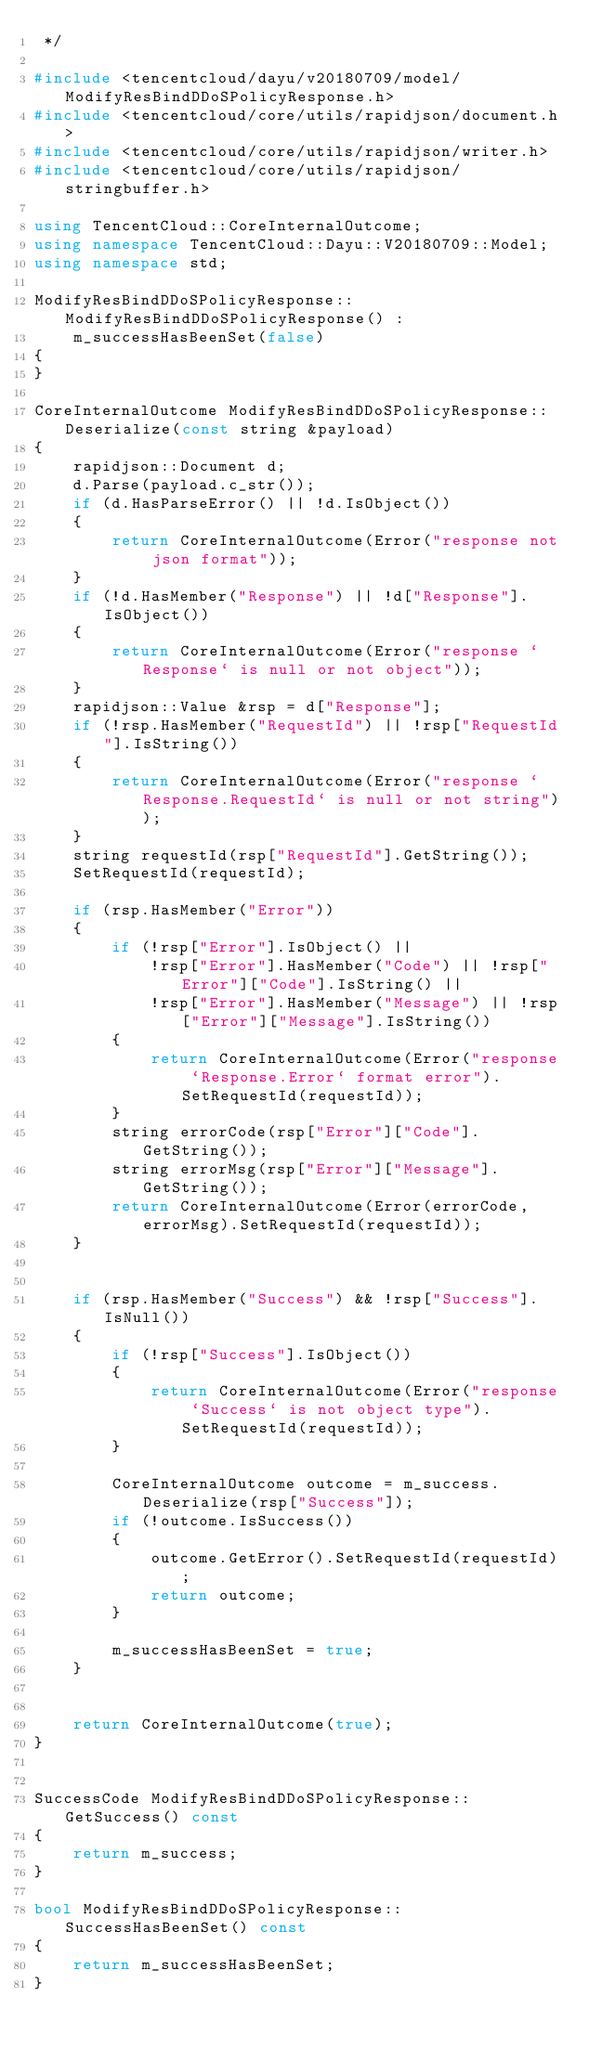Convert code to text. <code><loc_0><loc_0><loc_500><loc_500><_C++_> */

#include <tencentcloud/dayu/v20180709/model/ModifyResBindDDoSPolicyResponse.h>
#include <tencentcloud/core/utils/rapidjson/document.h>
#include <tencentcloud/core/utils/rapidjson/writer.h>
#include <tencentcloud/core/utils/rapidjson/stringbuffer.h>

using TencentCloud::CoreInternalOutcome;
using namespace TencentCloud::Dayu::V20180709::Model;
using namespace std;

ModifyResBindDDoSPolicyResponse::ModifyResBindDDoSPolicyResponse() :
    m_successHasBeenSet(false)
{
}

CoreInternalOutcome ModifyResBindDDoSPolicyResponse::Deserialize(const string &payload)
{
    rapidjson::Document d;
    d.Parse(payload.c_str());
    if (d.HasParseError() || !d.IsObject())
    {
        return CoreInternalOutcome(Error("response not json format"));
    }
    if (!d.HasMember("Response") || !d["Response"].IsObject())
    {
        return CoreInternalOutcome(Error("response `Response` is null or not object"));
    }
    rapidjson::Value &rsp = d["Response"];
    if (!rsp.HasMember("RequestId") || !rsp["RequestId"].IsString())
    {
        return CoreInternalOutcome(Error("response `Response.RequestId` is null or not string"));
    }
    string requestId(rsp["RequestId"].GetString());
    SetRequestId(requestId);

    if (rsp.HasMember("Error"))
    {
        if (!rsp["Error"].IsObject() ||
            !rsp["Error"].HasMember("Code") || !rsp["Error"]["Code"].IsString() ||
            !rsp["Error"].HasMember("Message") || !rsp["Error"]["Message"].IsString())
        {
            return CoreInternalOutcome(Error("response `Response.Error` format error").SetRequestId(requestId));
        }
        string errorCode(rsp["Error"]["Code"].GetString());
        string errorMsg(rsp["Error"]["Message"].GetString());
        return CoreInternalOutcome(Error(errorCode, errorMsg).SetRequestId(requestId));
    }


    if (rsp.HasMember("Success") && !rsp["Success"].IsNull())
    {
        if (!rsp["Success"].IsObject())
        {
            return CoreInternalOutcome(Error("response `Success` is not object type").SetRequestId(requestId));
        }

        CoreInternalOutcome outcome = m_success.Deserialize(rsp["Success"]);
        if (!outcome.IsSuccess())
        {
            outcome.GetError().SetRequestId(requestId);
            return outcome;
        }

        m_successHasBeenSet = true;
    }


    return CoreInternalOutcome(true);
}


SuccessCode ModifyResBindDDoSPolicyResponse::GetSuccess() const
{
    return m_success;
}

bool ModifyResBindDDoSPolicyResponse::SuccessHasBeenSet() const
{
    return m_successHasBeenSet;
}


</code> 